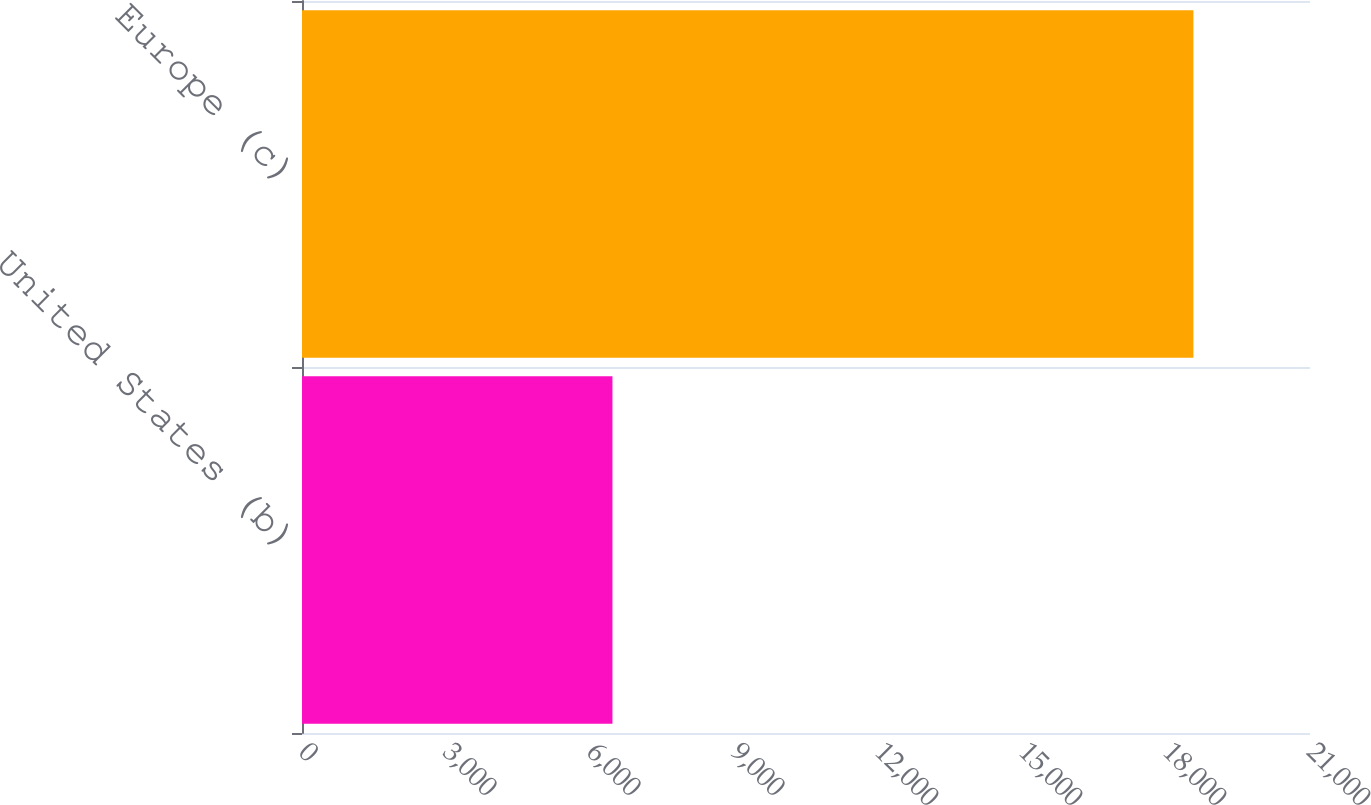<chart> <loc_0><loc_0><loc_500><loc_500><bar_chart><fcel>United States (b)<fcel>Europe (c)<nl><fcel>6468<fcel>18571<nl></chart> 